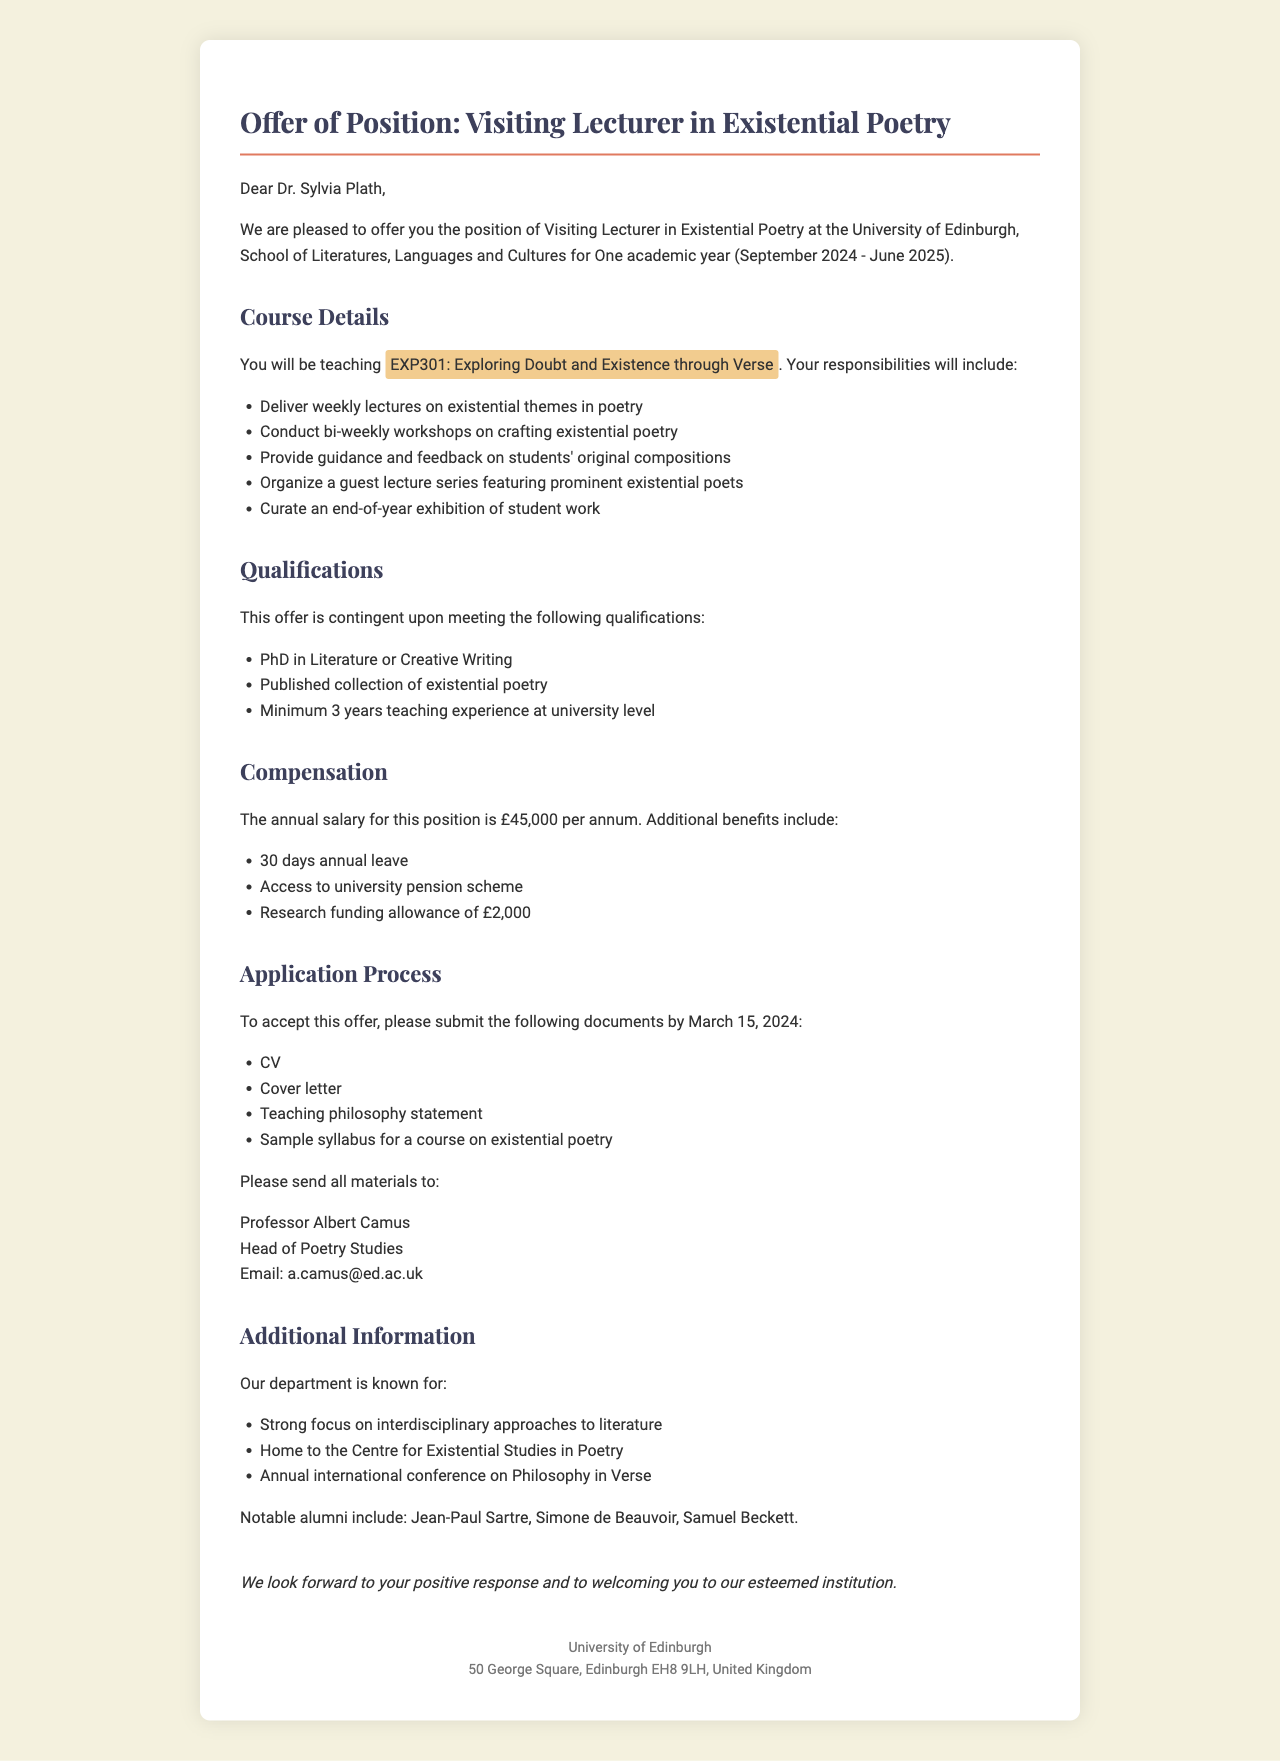What is the position title? The position title is explicitly stated in the document as the role being offered to Dr. Sylvia Plath.
Answer: Visiting Lecturer in Existential Poetry What is the duration of the appointment? The duration of the appointment is specified in the document detailing the time frame of employment.
Answer: One academic year (September 2024 - June 2025) What is the annual salary for this position? The salary amount is provided in the compensation section of the document outlining financial terms.
Answer: £45,000 per annum Who is the contact person for accepting the offer? The document specifies a contact person along with their title and email for further correspondence.
Answer: Professor Albert Camus What is one of the qualifications required for this position? The qualifications section lists specific criteria that must be met, and one of them is readily identifiable.
Answer: PhD in Literature or Creative Writing How many days of annual leave are included? The benefits section mentions the number of annual leave days that the lecturer can expect.
Answer: 30 days annual leave What is one strength of the department mentioned? The document outlines various strengths related to the department, describing its academic focus and achievements.
Answer: Strong focus on interdisciplinary approaches to literature What is the deadline for submitting application materials? The deadline for submission is clearly indicated in the application process section of the letter.
Answer: March 15, 2024 